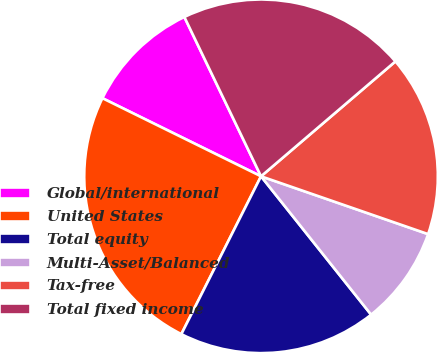Convert chart to OTSL. <chart><loc_0><loc_0><loc_500><loc_500><pie_chart><fcel>Global/international<fcel>United States<fcel>Total equity<fcel>Multi-Asset/Balanced<fcel>Tax-free<fcel>Total fixed income<nl><fcel>10.58%<fcel>24.84%<fcel>18.14%<fcel>9.0%<fcel>16.56%<fcel>20.88%<nl></chart> 